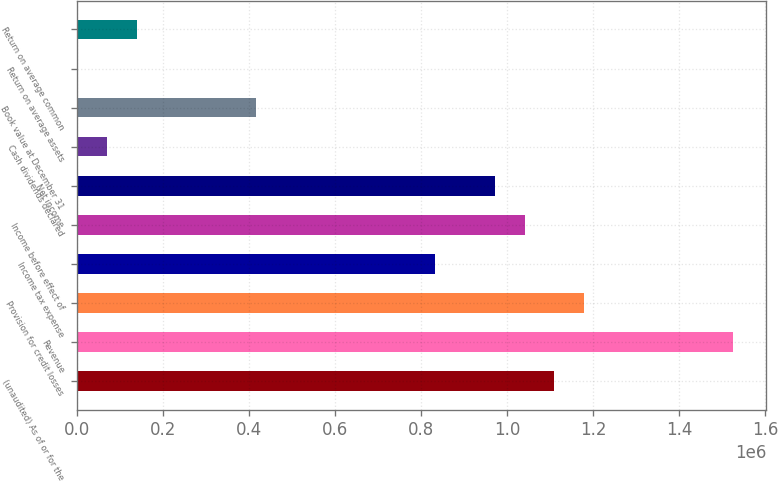<chart> <loc_0><loc_0><loc_500><loc_500><bar_chart><fcel>(unaudited) As of or for the<fcel>Revenue<fcel>Provision for credit losses<fcel>Income tax expense<fcel>Income before effect of<fcel>Net income<fcel>Cash dividends declared<fcel>Book value at December 31<fcel>Return on average assets<fcel>Return on average common<nl><fcel>1.10972e+06<fcel>1.52586e+06<fcel>1.17908e+06<fcel>832290<fcel>1.04036e+06<fcel>971005<fcel>69357.7<fcel>416145<fcel>0.23<fcel>138715<nl></chart> 